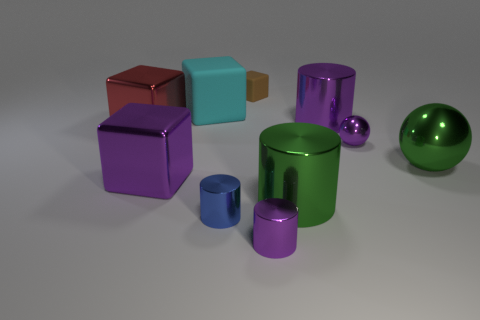Subtract all large rubber blocks. How many blocks are left? 3 Subtract all blue cylinders. How many cylinders are left? 3 Subtract 2 cubes. How many cubes are left? 2 Subtract all balls. How many objects are left? 8 Subtract all purple cylinders. How many purple spheres are left? 1 Subtract all big purple things. Subtract all green objects. How many objects are left? 6 Add 5 large rubber things. How many large rubber things are left? 6 Add 10 tiny cyan shiny spheres. How many tiny cyan shiny spheres exist? 10 Subtract 1 purple cylinders. How many objects are left? 9 Subtract all purple balls. Subtract all green cubes. How many balls are left? 1 